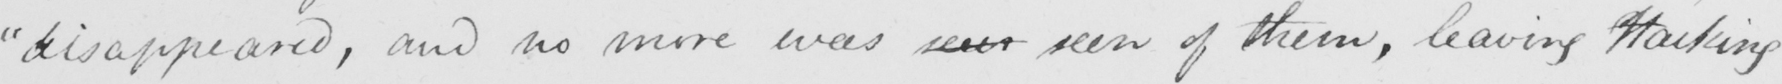Please provide the text content of this handwritten line. " disappeared , and no more was seen seen of them , leaving Hacking 